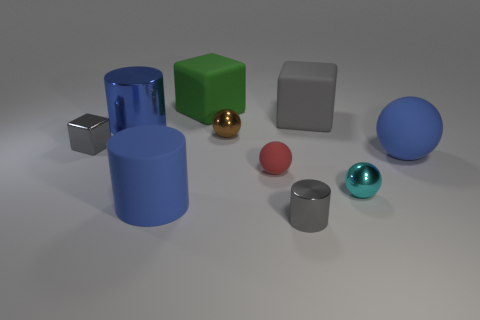There is a gray thing that is on the left side of the gray cylinder; does it have the same size as the big blue shiny cylinder?
Your answer should be very brief. No. Is there anything else that is the same shape as the big metal thing?
Your answer should be compact. Yes. Does the large ball have the same material as the gray cube that is on the right side of the gray metallic block?
Your response must be concise. Yes. How many cyan things are small objects or tiny cylinders?
Give a very brief answer. 1. Are any tiny red rubber objects visible?
Ensure brevity in your answer.  Yes. Are there any tiny rubber things to the left of the metallic cylinder on the right side of the small sphere to the left of the red sphere?
Offer a very short reply. Yes. Are there any other things that are the same size as the brown thing?
Give a very brief answer. Yes. There is a large gray matte object; is its shape the same as the blue rubber thing that is on the right side of the cyan metal ball?
Ensure brevity in your answer.  No. There is a small object left of the ball behind the small gray thing that is left of the green matte thing; what color is it?
Ensure brevity in your answer.  Gray. What number of things are gray objects in front of the tiny brown sphere or large rubber objects in front of the big matte ball?
Ensure brevity in your answer.  3. 